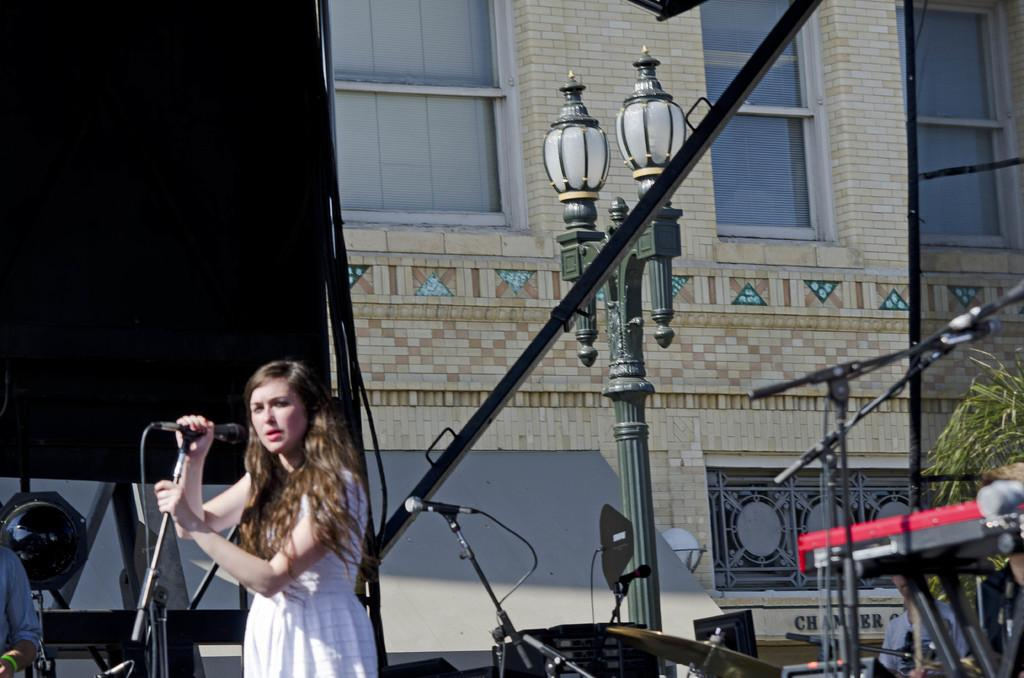Who is the main subject in the image? There is a woman in the image. What is the woman holding in her hand? The woman is holding a microphone in her hand. What can be seen in the background of the image? There is a street light and a building in the background of the image. What else is visible in the image besides the woman and the background? There are musical instruments visible in the image. What type of sponge is being used to create a rhythm in the image? There is no sponge or rhythm-creating activity present in the image. What operation is the woman performing with the microphone in the image? The image does not show the woman performing any specific operation with the microphone; she is simply holding it. 